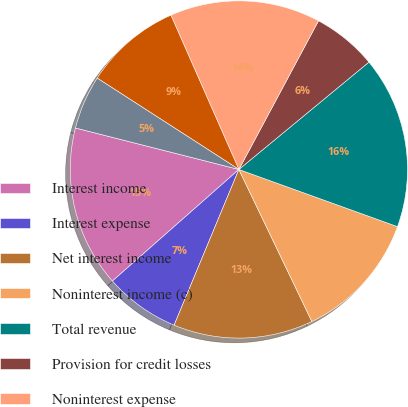<chart> <loc_0><loc_0><loc_500><loc_500><pie_chart><fcel>Interest income<fcel>Interest expense<fcel>Net interest income<fcel>Noninterest income (c)<fcel>Total revenue<fcel>Provision for credit losses<fcel>Noninterest expense<fcel>Income from continuing<fcel>Income taxes<nl><fcel>15.46%<fcel>7.22%<fcel>13.4%<fcel>12.37%<fcel>16.49%<fcel>6.19%<fcel>14.43%<fcel>9.28%<fcel>5.16%<nl></chart> 